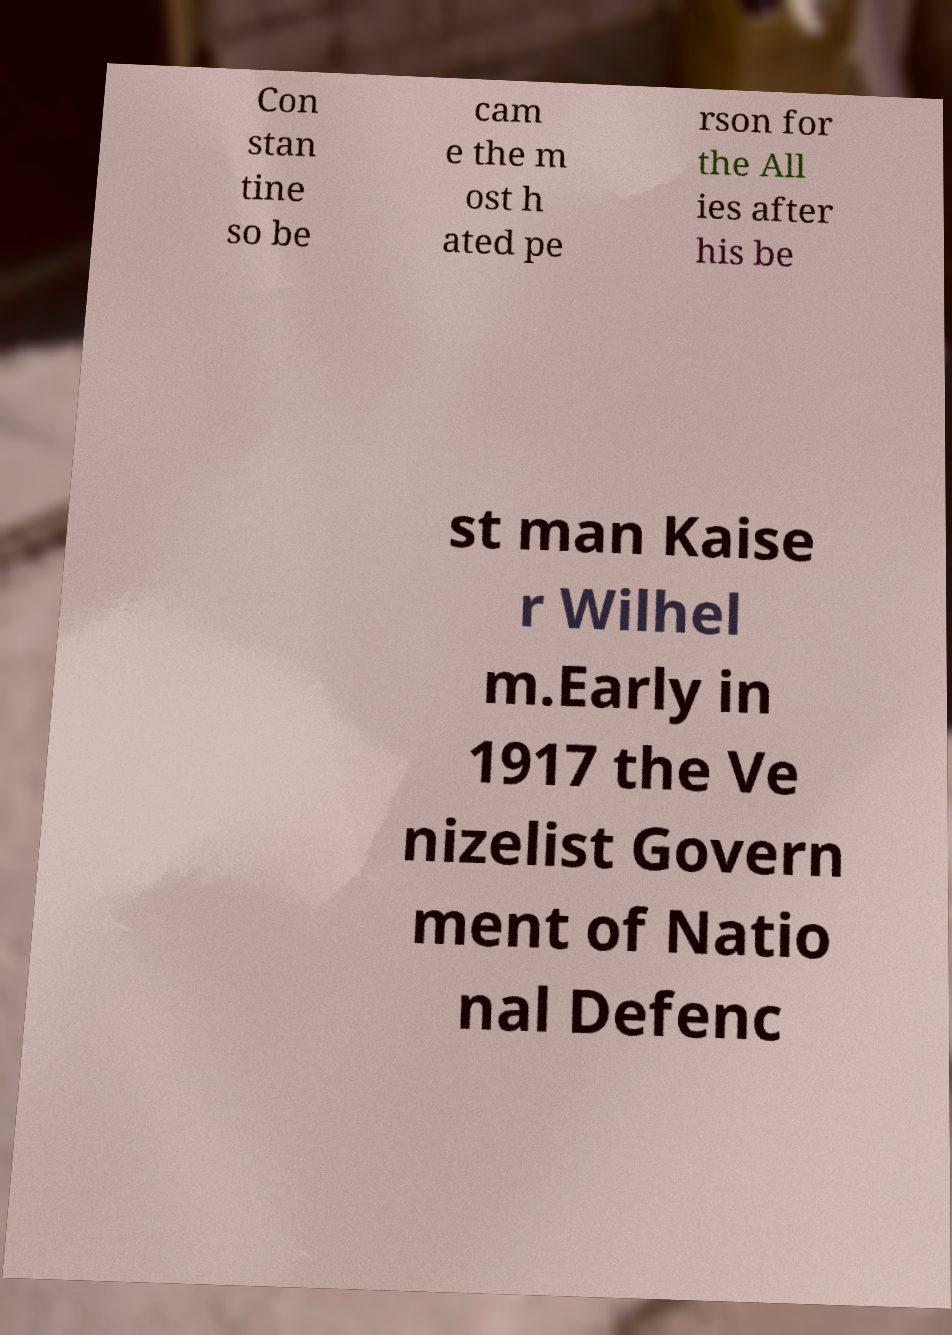I need the written content from this picture converted into text. Can you do that? Con stan tine so be cam e the m ost h ated pe rson for the All ies after his be st man Kaise r Wilhel m.Early in 1917 the Ve nizelist Govern ment of Natio nal Defenc 